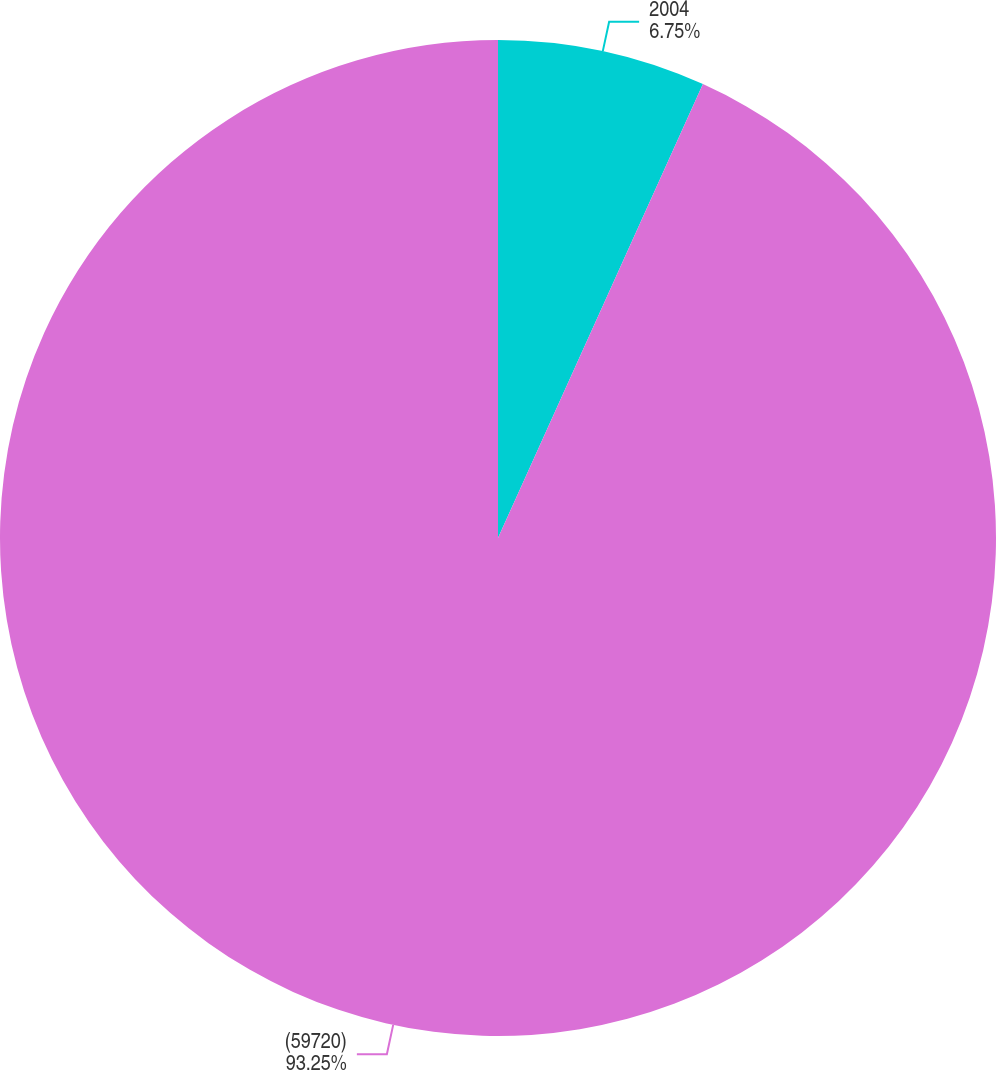Convert chart. <chart><loc_0><loc_0><loc_500><loc_500><pie_chart><fcel>2004<fcel>(59720)<nl><fcel>6.75%<fcel>93.25%<nl></chart> 